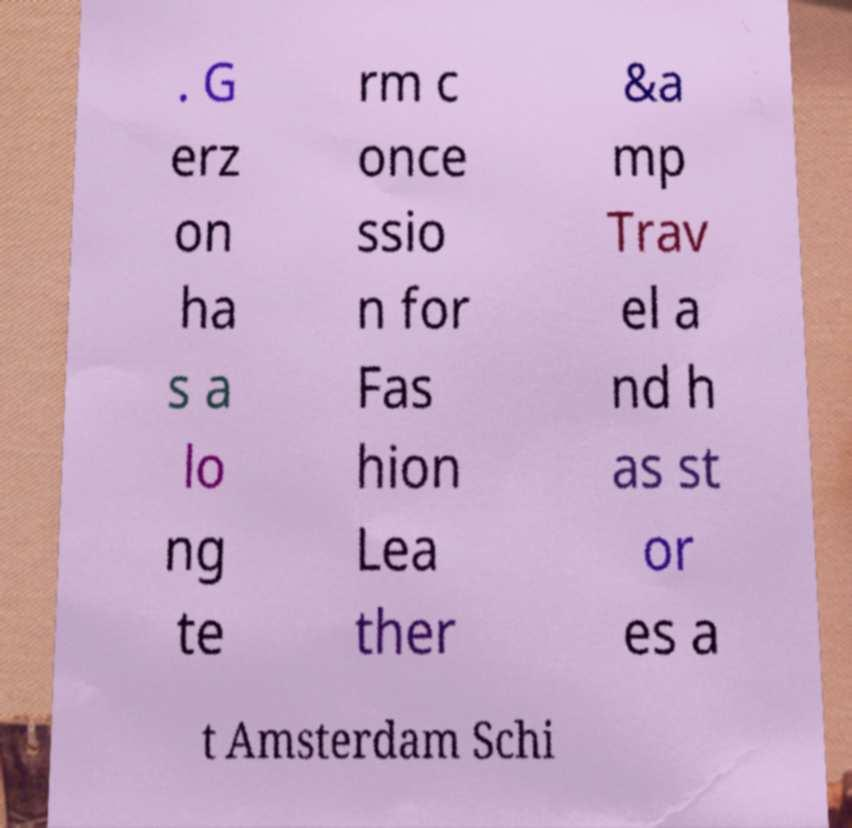Please identify and transcribe the text found in this image. . G erz on ha s a lo ng te rm c once ssio n for Fas hion Lea ther &a mp Trav el a nd h as st or es a t Amsterdam Schi 